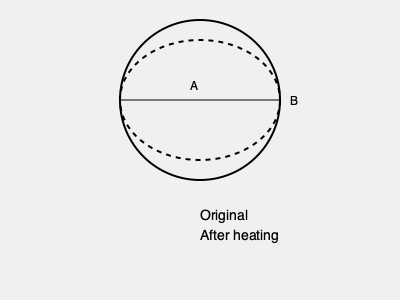A cylindrical steam pipe is subjected to high temperatures during operation. Which of the following best represents the cross-section of the pipe after heating, assuming uniform thermal expansion?

A) A perfect circle with a larger diameter
B) An ellipse with a slightly larger horizontal axis To determine the correct cross-section of a cylindrical steam pipe after heating, we need to consider the following factors:

1. Thermal expansion: When heated, materials generally expand in all directions.

2. Constraint conditions: The pipe is typically constrained along its length by supports or connections, which can affect its expansion behavior.

3. Material properties: The coefficient of thermal expansion for the pipe material (usually steel or alloy) is uniform in all directions.

4. Stress distribution: Due to the cylindrical shape and constraints, the stress distribution is not uniform across the cross-section.

Step-by-step analysis:

1. Longitudinal expansion: The pipe is constrained along its length, limiting expansion in this direction.

2. Radial expansion: The pipe can expand more freely in the radial direction.

3. Hoop stress: Circumferential stress develops due to internal pressure and thermal expansion.

4. Resulting shape: The combination of these factors leads to a slightly non-uniform expansion.

5. Cross-section deformation: The cross-section becomes slightly elliptical, with the major axis oriented horizontally.

The expansion is typically small, with the difference between vertical and horizontal diameters being minimal. However, this slight elliptical shape is more accurate than a perfect circle.
Answer: B 